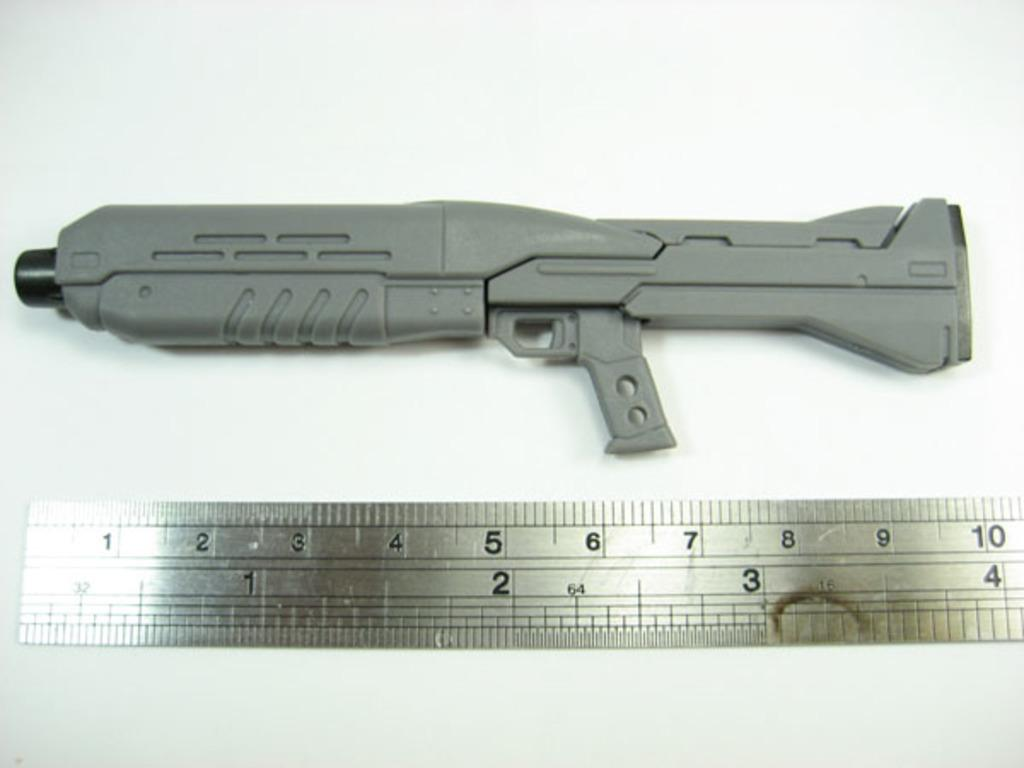<image>
Relay a brief, clear account of the picture shown. A gun sitting above part of a ruler that ranges from 1 to 10 inches. 